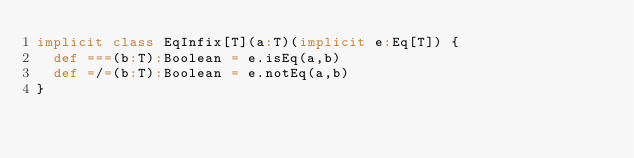Convert code to text. <code><loc_0><loc_0><loc_500><loc_500><_Scala_>implicit class EqInfix[T](a:T)(implicit e:Eq[T]) {
  def ===(b:T):Boolean = e.isEq(a,b)
  def =/=(b:T):Boolean = e.notEq(a,b)
}
</code> 